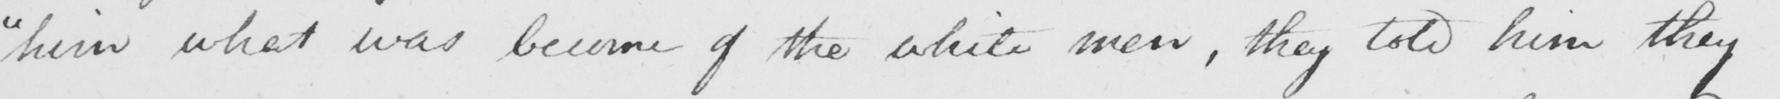Can you tell me what this handwritten text says? " him what was become of the white men , they told him they 